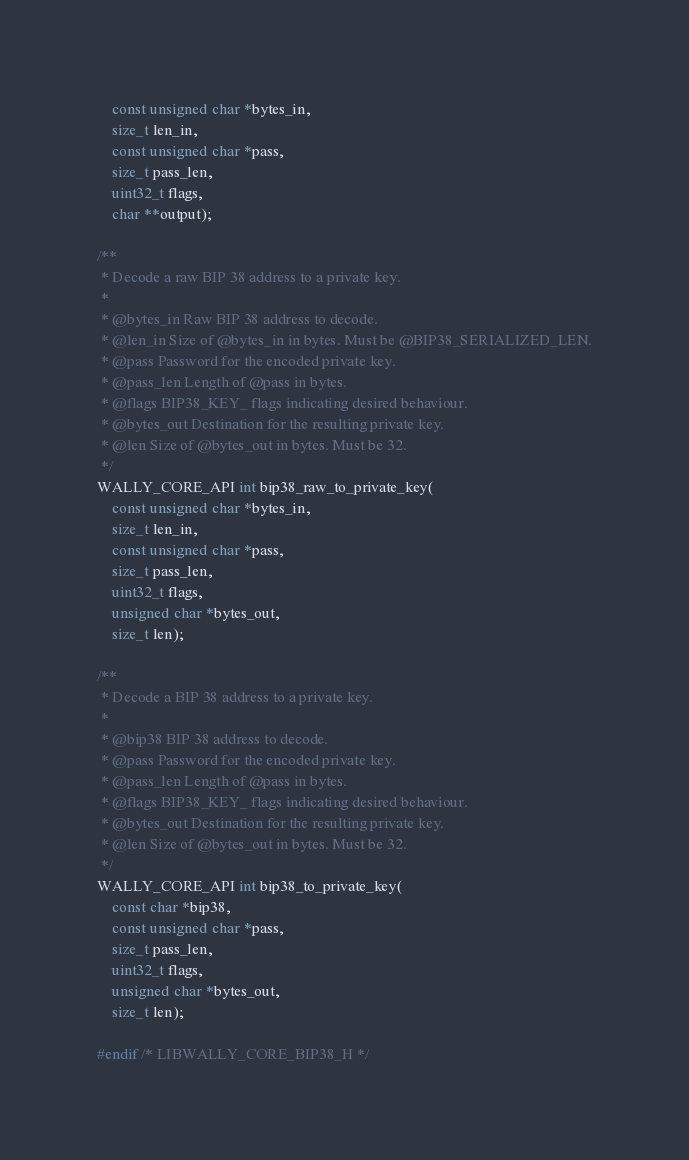<code> <loc_0><loc_0><loc_500><loc_500><_C_>    const unsigned char *bytes_in,
    size_t len_in,
    const unsigned char *pass,
    size_t pass_len,
    uint32_t flags,
    char **output);

/**
 * Decode a raw BIP 38 address to a private key.
 *
 * @bytes_in Raw BIP 38 address to decode.
 * @len_in Size of @bytes_in in bytes. Must be @BIP38_SERIALIZED_LEN.
 * @pass Password for the encoded private key.
 * @pass_len Length of @pass in bytes.
 * @flags BIP38_KEY_ flags indicating desired behaviour.
 * @bytes_out Destination for the resulting private key.
 * @len Size of @bytes_out in bytes. Must be 32.
 */
WALLY_CORE_API int bip38_raw_to_private_key(
    const unsigned char *bytes_in,
    size_t len_in,
    const unsigned char *pass,
    size_t pass_len,
    uint32_t flags,
    unsigned char *bytes_out,
    size_t len);

/**
 * Decode a BIP 38 address to a private key.
 *
 * @bip38 BIP 38 address to decode.
 * @pass Password for the encoded private key.
 * @pass_len Length of @pass in bytes.
 * @flags BIP38_KEY_ flags indicating desired behaviour.
 * @bytes_out Destination for the resulting private key.
 * @len Size of @bytes_out in bytes. Must be 32.
 */
WALLY_CORE_API int bip38_to_private_key(
    const char *bip38,
    const unsigned char *pass,
    size_t pass_len,
    uint32_t flags,
    unsigned char *bytes_out,
    size_t len);

#endif /* LIBWALLY_CORE_BIP38_H */
</code> 